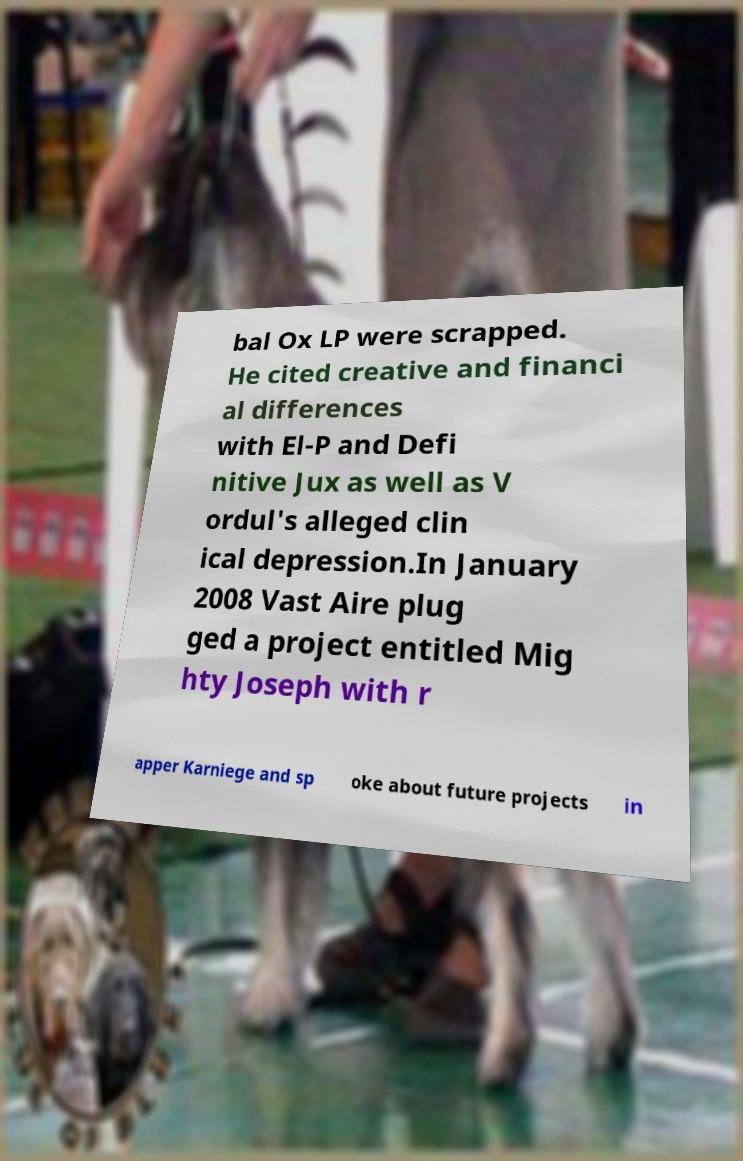Can you accurately transcribe the text from the provided image for me? bal Ox LP were scrapped. He cited creative and financi al differences with El-P and Defi nitive Jux as well as V ordul's alleged clin ical depression.In January 2008 Vast Aire plug ged a project entitled Mig hty Joseph with r apper Karniege and sp oke about future projects in 